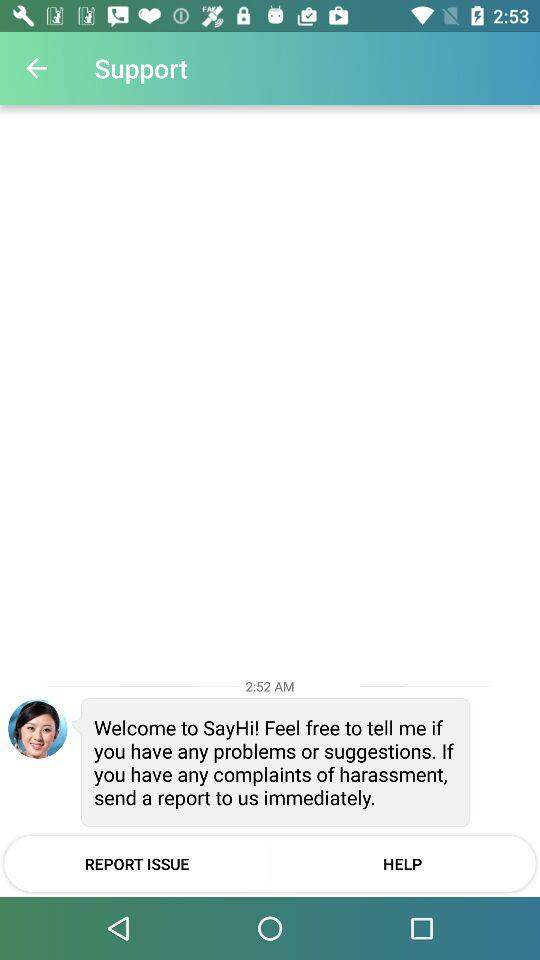At what time was the message from the support team received? The message from the support team was received at 2:52 a.m. 